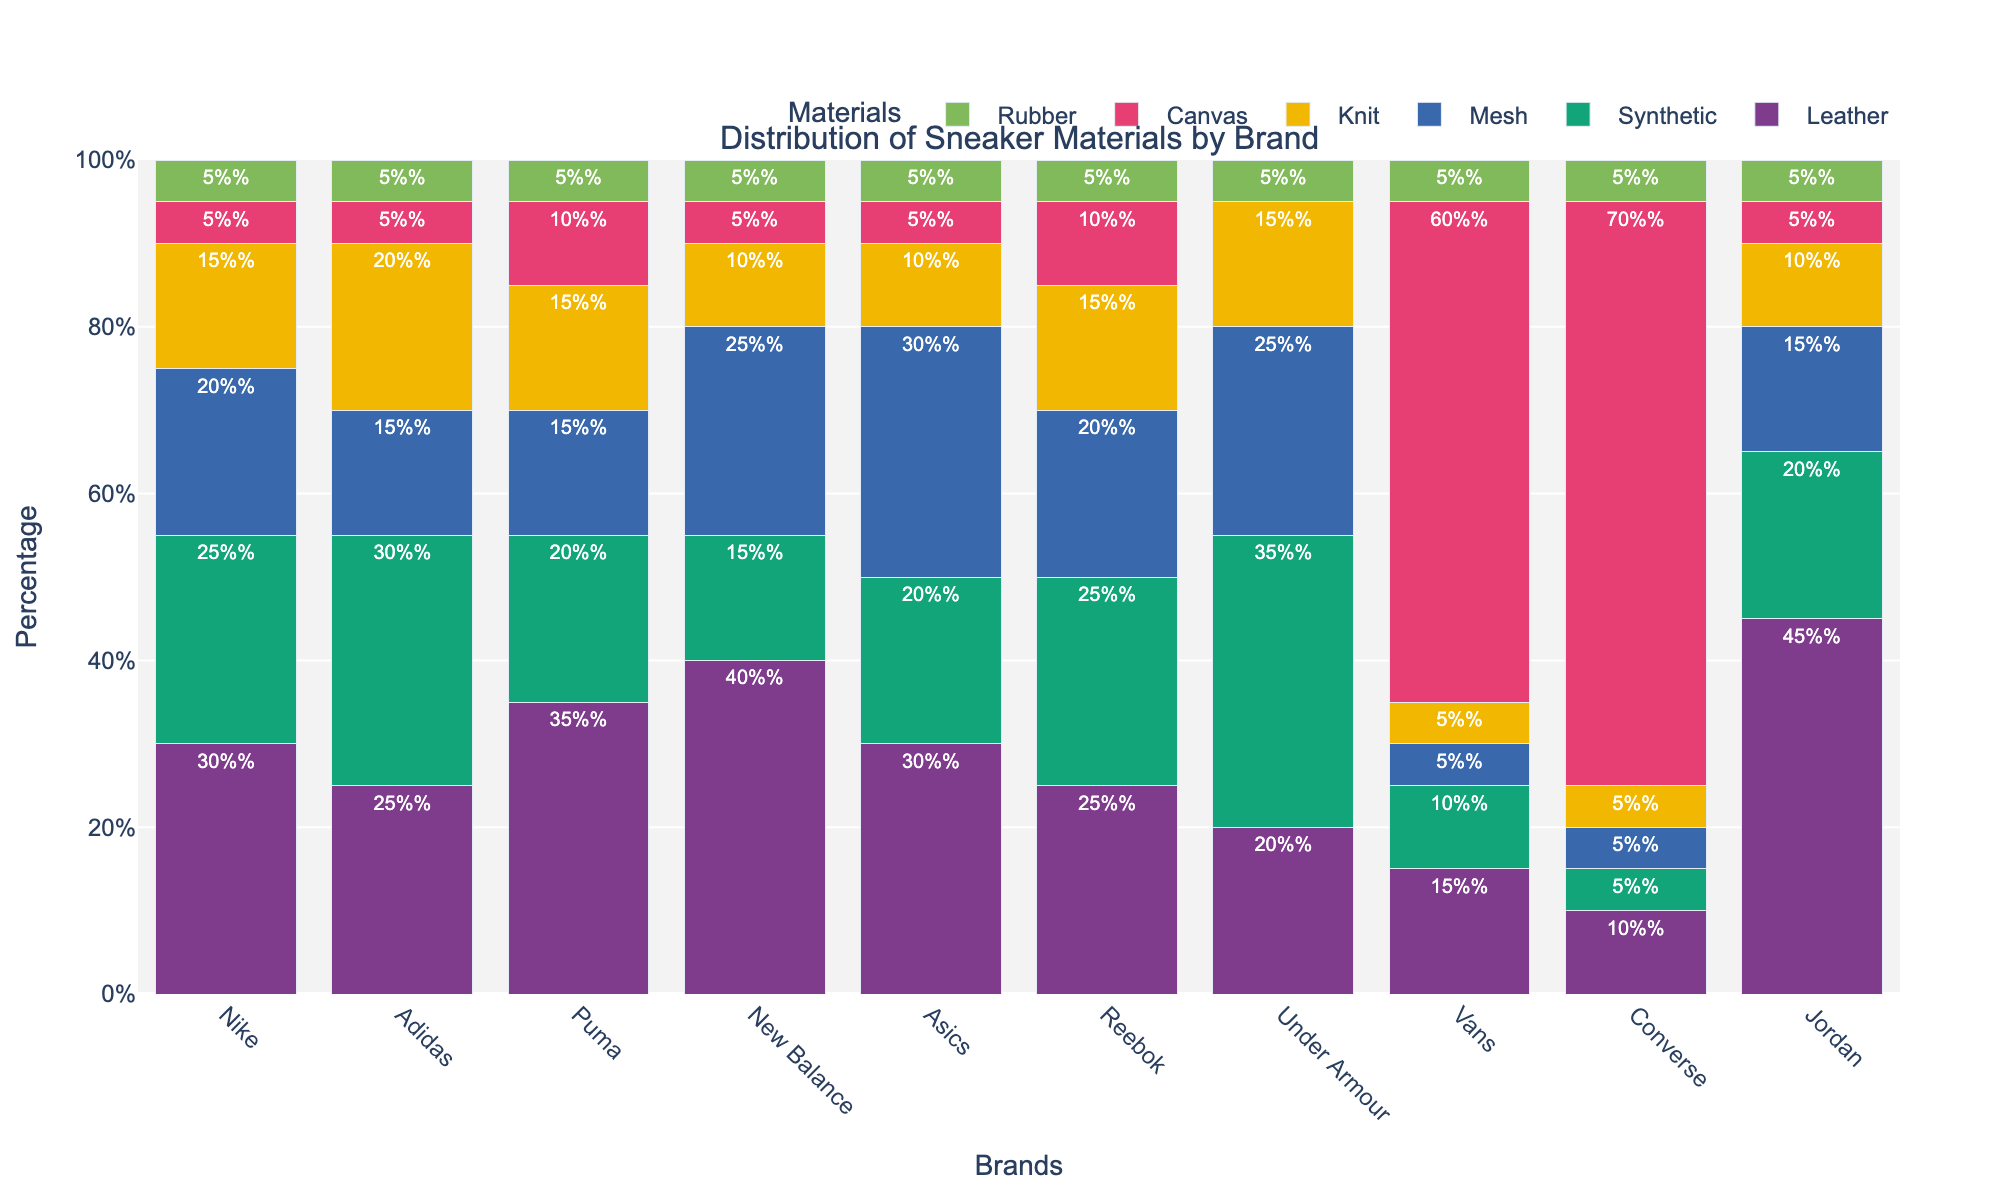What is the most commonly used material for producing sneakers by Nike? The bar representing leather in the Nike column is the tallest, indicating the highest percentage.
Answer: Leather Which brand uses the highest percentage of canvas in their sneakers? The tallest bar in the canvas category belongs to Converse, indicating that they use the highest percentage of canvas.
Answer: Converse What is the total percentage of synthetic material used in production by Adidas and Puma combined? Adidas uses 30% synthetic material and Puma uses 20%, adding up to 50%.
Answer: 50% How does the use of knit material in Asics compare with that in New Balance? Asics uses 10% knit material while New Balance also uses 10%, so they are equal.
Answer: Equal Which material is least used by Vans? For Vans, the smallest bar is for mesh, indicating it is the least used material at 5%.
Answer: Mesh What is the difference in the percentage of leather between Jordan and Converse? Jordan uses 45% leather and Converse uses 10%. The difference is 45% - 10% = 35%.
Answer: 35% Among all brands, which two have equal percentages for synthetic, mesh, and knit materials? Both Nike and Reebok use 25% synthetic, 20% mesh, and 15% knit.
Answer: Nike and Reebok Which brand uses the least amount of rubber, and is it less or more than 10%? All brands use an equal amount of rubber at 5%, which is less than 10%.
Answer: Less than 10% What is the combined percentage of mesh material used by Puma and Under Armour? Puma and Under Armour use 15% and 25% mesh, respectively. Combined, this is 15% + 25% = 40%.
Answer: 40% If we average the percentage of leather used by Nike, Adidas, and Puma, what do we get? Nike uses 30% leather, Adidas uses 25%, and Puma uses 35%. The average is (30% + 25% + 35%) / 3 = 30%.
Answer: 30% 